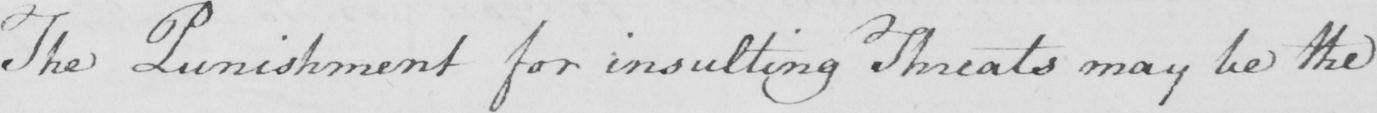What text is written in this handwritten line? The Punishment for insulting Threats may be the 